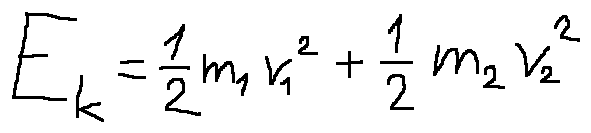Convert formula to latex. <formula><loc_0><loc_0><loc_500><loc_500>E _ { k } = \frac { 1 } { 2 } m _ { 1 } v _ { 1 } ^ { 2 } + \frac { 1 } { 2 } m _ { 2 } v _ { 2 } ^ { 2 }</formula> 